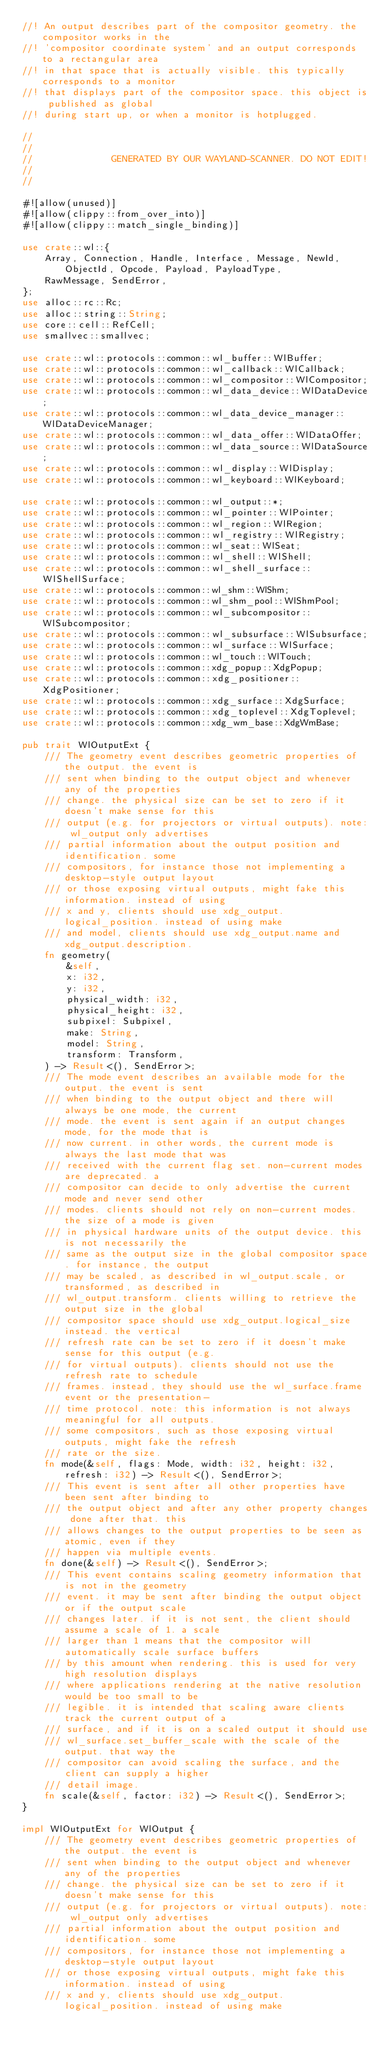Convert code to text. <code><loc_0><loc_0><loc_500><loc_500><_Rust_>//! An output describes part of the compositor geometry. the compositor works in the
//! 'compositor coordinate system' and an output corresponds to a rectangular area
//! in that space that is actually visible. this typically corresponds to a monitor
//! that displays part of the compositor space. this object is published as global
//! during start up, or when a monitor is hotplugged.

//
//
//              GENERATED BY OUR WAYLAND-SCANNER. DO NOT EDIT!
//
//

#![allow(unused)]
#![allow(clippy::from_over_into)]
#![allow(clippy::match_single_binding)]

use crate::wl::{
    Array, Connection, Handle, Interface, Message, NewId, ObjectId, Opcode, Payload, PayloadType,
    RawMessage, SendError,
};
use alloc::rc::Rc;
use alloc::string::String;
use core::cell::RefCell;
use smallvec::smallvec;

use crate::wl::protocols::common::wl_buffer::WlBuffer;
use crate::wl::protocols::common::wl_callback::WlCallback;
use crate::wl::protocols::common::wl_compositor::WlCompositor;
use crate::wl::protocols::common::wl_data_device::WlDataDevice;
use crate::wl::protocols::common::wl_data_device_manager::WlDataDeviceManager;
use crate::wl::protocols::common::wl_data_offer::WlDataOffer;
use crate::wl::protocols::common::wl_data_source::WlDataSource;
use crate::wl::protocols::common::wl_display::WlDisplay;
use crate::wl::protocols::common::wl_keyboard::WlKeyboard;

use crate::wl::protocols::common::wl_output::*;
use crate::wl::protocols::common::wl_pointer::WlPointer;
use crate::wl::protocols::common::wl_region::WlRegion;
use crate::wl::protocols::common::wl_registry::WlRegistry;
use crate::wl::protocols::common::wl_seat::WlSeat;
use crate::wl::protocols::common::wl_shell::WlShell;
use crate::wl::protocols::common::wl_shell_surface::WlShellSurface;
use crate::wl::protocols::common::wl_shm::WlShm;
use crate::wl::protocols::common::wl_shm_pool::WlShmPool;
use crate::wl::protocols::common::wl_subcompositor::WlSubcompositor;
use crate::wl::protocols::common::wl_subsurface::WlSubsurface;
use crate::wl::protocols::common::wl_surface::WlSurface;
use crate::wl::protocols::common::wl_touch::WlTouch;
use crate::wl::protocols::common::xdg_popup::XdgPopup;
use crate::wl::protocols::common::xdg_positioner::XdgPositioner;
use crate::wl::protocols::common::xdg_surface::XdgSurface;
use crate::wl::protocols::common::xdg_toplevel::XdgToplevel;
use crate::wl::protocols::common::xdg_wm_base::XdgWmBase;

pub trait WlOutputExt {
    /// The geometry event describes geometric properties of the output. the event is
    /// sent when binding to the output object and whenever any of the properties
    /// change. the physical size can be set to zero if it doesn't make sense for this
    /// output (e.g. for projectors or virtual outputs). note: wl_output only advertises
    /// partial information about the output position and identification. some
    /// compositors, for instance those not implementing a desktop-style output layout
    /// or those exposing virtual outputs, might fake this information. instead of using
    /// x and y, clients should use xdg_output.logical_position. instead of using make
    /// and model, clients should use xdg_output.name and xdg_output.description.
    fn geometry(
        &self,
        x: i32,
        y: i32,
        physical_width: i32,
        physical_height: i32,
        subpixel: Subpixel,
        make: String,
        model: String,
        transform: Transform,
    ) -> Result<(), SendError>;
    /// The mode event describes an available mode for the output. the event is sent
    /// when binding to the output object and there will always be one mode, the current
    /// mode. the event is sent again if an output changes mode, for the mode that is
    /// now current. in other words, the current mode is always the last mode that was
    /// received with the current flag set. non-current modes are deprecated. a
    /// compositor can decide to only advertise the current mode and never send other
    /// modes. clients should not rely on non-current modes. the size of a mode is given
    /// in physical hardware units of the output device. this is not necessarily the
    /// same as the output size in the global compositor space. for instance, the output
    /// may be scaled, as described in wl_output.scale, or transformed, as described in
    /// wl_output.transform. clients willing to retrieve the output size in the global
    /// compositor space should use xdg_output.logical_size instead. the vertical
    /// refresh rate can be set to zero if it doesn't make sense for this output (e.g.
    /// for virtual outputs). clients should not use the refresh rate to schedule
    /// frames. instead, they should use the wl_surface.frame event or the presentation-
    /// time protocol. note: this information is not always meaningful for all outputs.
    /// some compositors, such as those exposing virtual outputs, might fake the refresh
    /// rate or the size.
    fn mode(&self, flags: Mode, width: i32, height: i32, refresh: i32) -> Result<(), SendError>;
    /// This event is sent after all other properties have been sent after binding to
    /// the output object and after any other property changes done after that. this
    /// allows changes to the output properties to be seen as atomic, even if they
    /// happen via multiple events.
    fn done(&self) -> Result<(), SendError>;
    /// This event contains scaling geometry information that is not in the geometry
    /// event. it may be sent after binding the output object or if the output scale
    /// changes later. if it is not sent, the client should assume a scale of 1. a scale
    /// larger than 1 means that the compositor will automatically scale surface buffers
    /// by this amount when rendering. this is used for very high resolution displays
    /// where applications rendering at the native resolution would be too small to be
    /// legible. it is intended that scaling aware clients track the current output of a
    /// surface, and if it is on a scaled output it should use
    /// wl_surface.set_buffer_scale with the scale of the output. that way the
    /// compositor can avoid scaling the surface, and the client can supply a higher
    /// detail image.
    fn scale(&self, factor: i32) -> Result<(), SendError>;
}

impl WlOutputExt for WlOutput {
    /// The geometry event describes geometric properties of the output. the event is
    /// sent when binding to the output object and whenever any of the properties
    /// change. the physical size can be set to zero if it doesn't make sense for this
    /// output (e.g. for projectors or virtual outputs). note: wl_output only advertises
    /// partial information about the output position and identification. some
    /// compositors, for instance those not implementing a desktop-style output layout
    /// or those exposing virtual outputs, might fake this information. instead of using
    /// x and y, clients should use xdg_output.logical_position. instead of using make</code> 